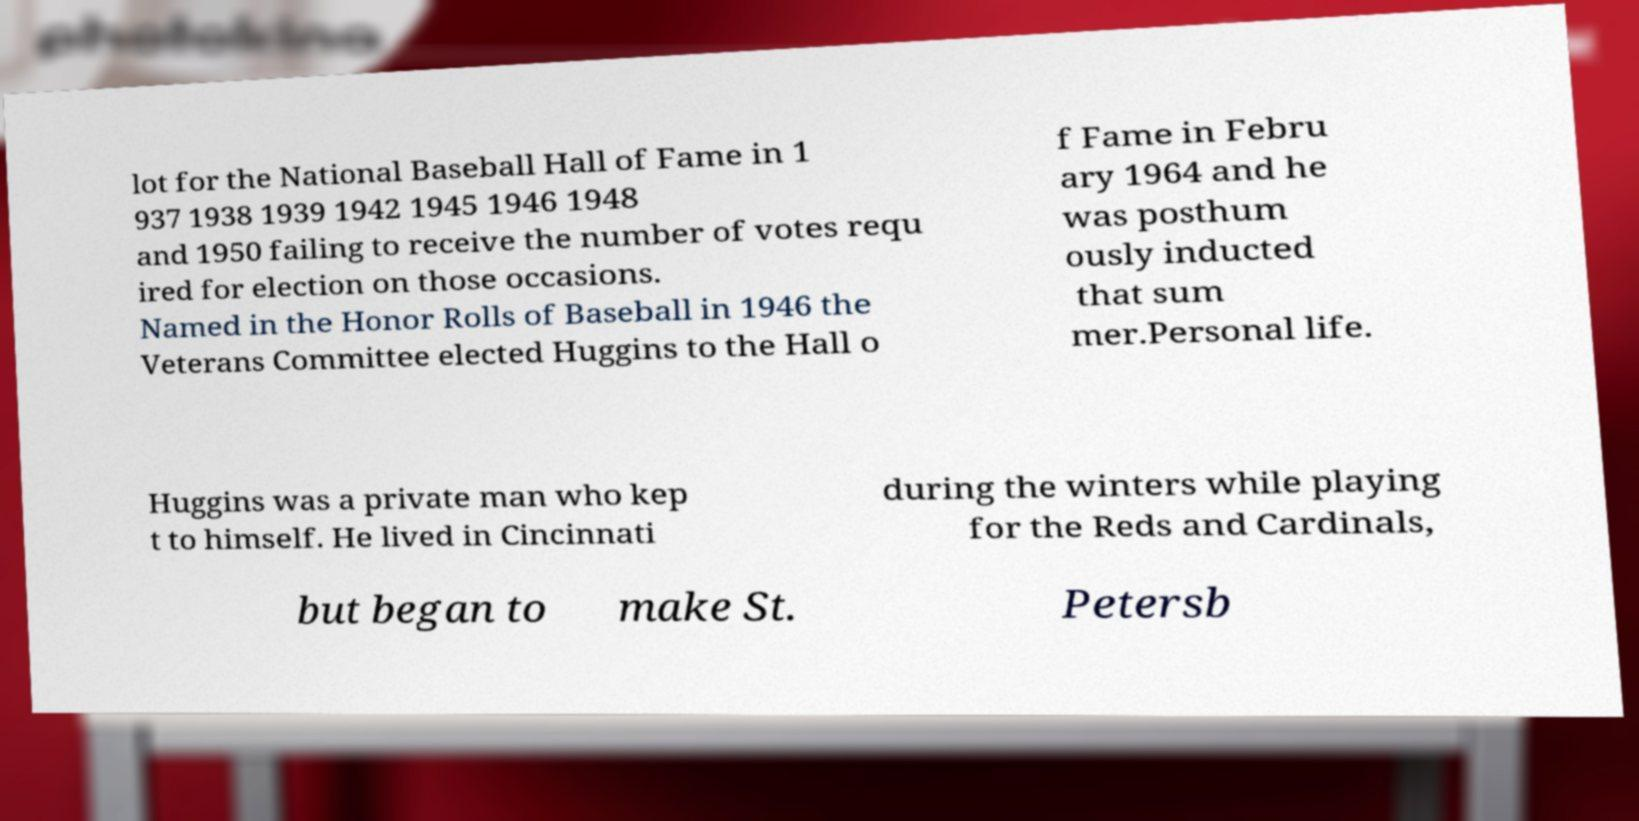What messages or text are displayed in this image? I need them in a readable, typed format. lot for the National Baseball Hall of Fame in 1 937 1938 1939 1942 1945 1946 1948 and 1950 failing to receive the number of votes requ ired for election on those occasions. Named in the Honor Rolls of Baseball in 1946 the Veterans Committee elected Huggins to the Hall o f Fame in Febru ary 1964 and he was posthum ously inducted that sum mer.Personal life. Huggins was a private man who kep t to himself. He lived in Cincinnati during the winters while playing for the Reds and Cardinals, but began to make St. Petersb 